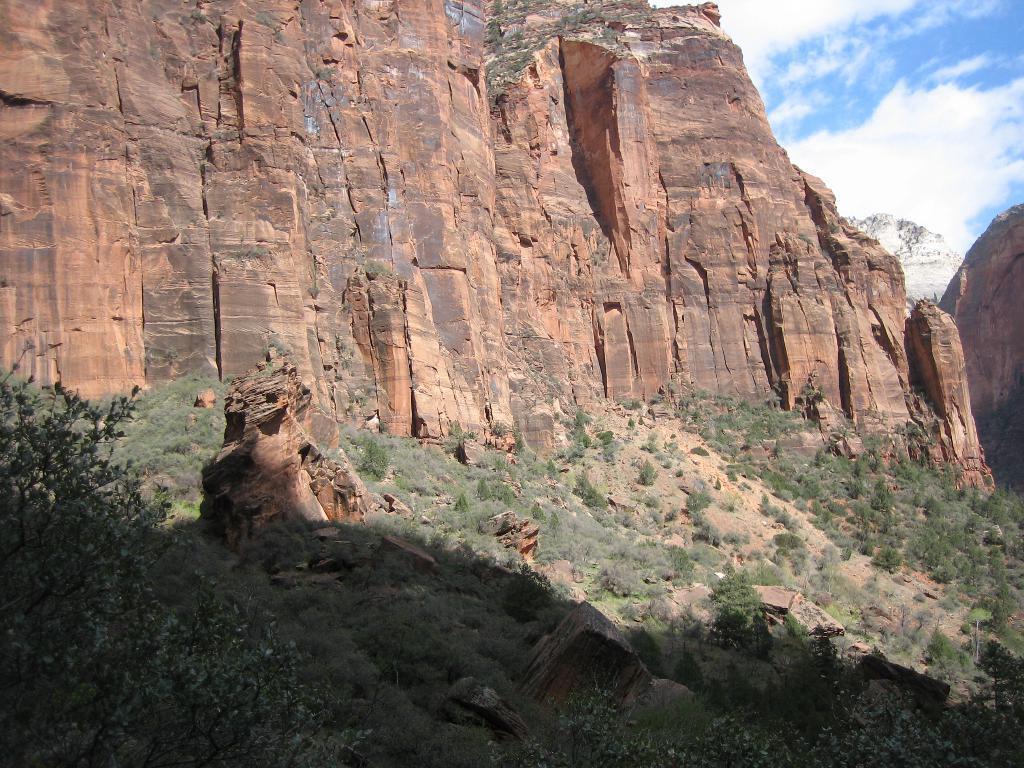Describe this image in one or two sentences. In this image I can see few plants in green color. In the background I can see few rocks, mountains and the sky is in blue and white color. 